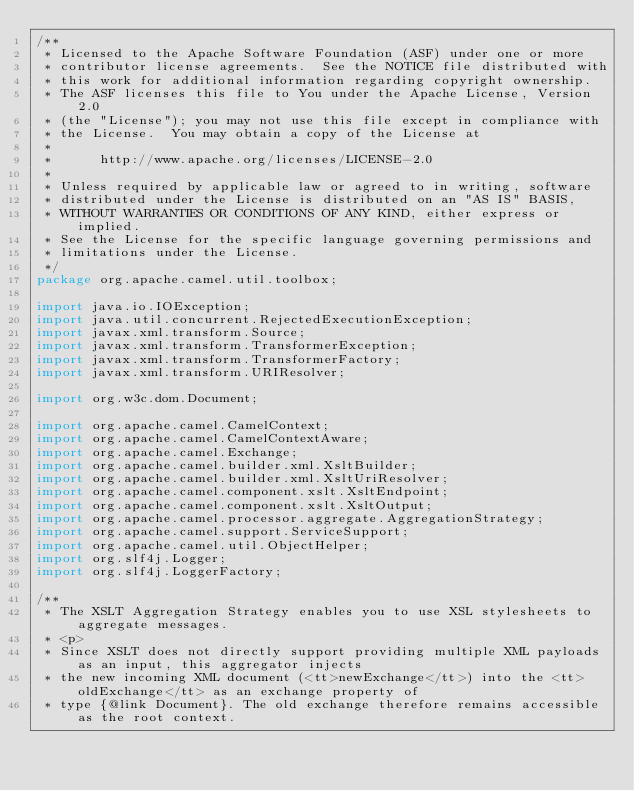Convert code to text. <code><loc_0><loc_0><loc_500><loc_500><_Java_>/**
 * Licensed to the Apache Software Foundation (ASF) under one or more
 * contributor license agreements.  See the NOTICE file distributed with
 * this work for additional information regarding copyright ownership.
 * The ASF licenses this file to You under the Apache License, Version 2.0
 * (the "License"); you may not use this file except in compliance with
 * the License.  You may obtain a copy of the License at
 *
 *      http://www.apache.org/licenses/LICENSE-2.0
 *
 * Unless required by applicable law or agreed to in writing, software
 * distributed under the License is distributed on an "AS IS" BASIS,
 * WITHOUT WARRANTIES OR CONDITIONS OF ANY KIND, either express or implied.
 * See the License for the specific language governing permissions and
 * limitations under the License.
 */
package org.apache.camel.util.toolbox;

import java.io.IOException;
import java.util.concurrent.RejectedExecutionException;
import javax.xml.transform.Source;
import javax.xml.transform.TransformerException;
import javax.xml.transform.TransformerFactory;
import javax.xml.transform.URIResolver;

import org.w3c.dom.Document;

import org.apache.camel.CamelContext;
import org.apache.camel.CamelContextAware;
import org.apache.camel.Exchange;
import org.apache.camel.builder.xml.XsltBuilder;
import org.apache.camel.builder.xml.XsltUriResolver;
import org.apache.camel.component.xslt.XsltEndpoint;
import org.apache.camel.component.xslt.XsltOutput;
import org.apache.camel.processor.aggregate.AggregationStrategy;
import org.apache.camel.support.ServiceSupport;
import org.apache.camel.util.ObjectHelper;
import org.slf4j.Logger;
import org.slf4j.LoggerFactory;

/**
 * The XSLT Aggregation Strategy enables you to use XSL stylesheets to aggregate messages.
 * <p>
 * Since XSLT does not directly support providing multiple XML payloads as an input, this aggregator injects
 * the new incoming XML document (<tt>newExchange</tt>) into the <tt>oldExchange</tt> as an exchange property of
 * type {@link Document}. The old exchange therefore remains accessible as the root context.</code> 